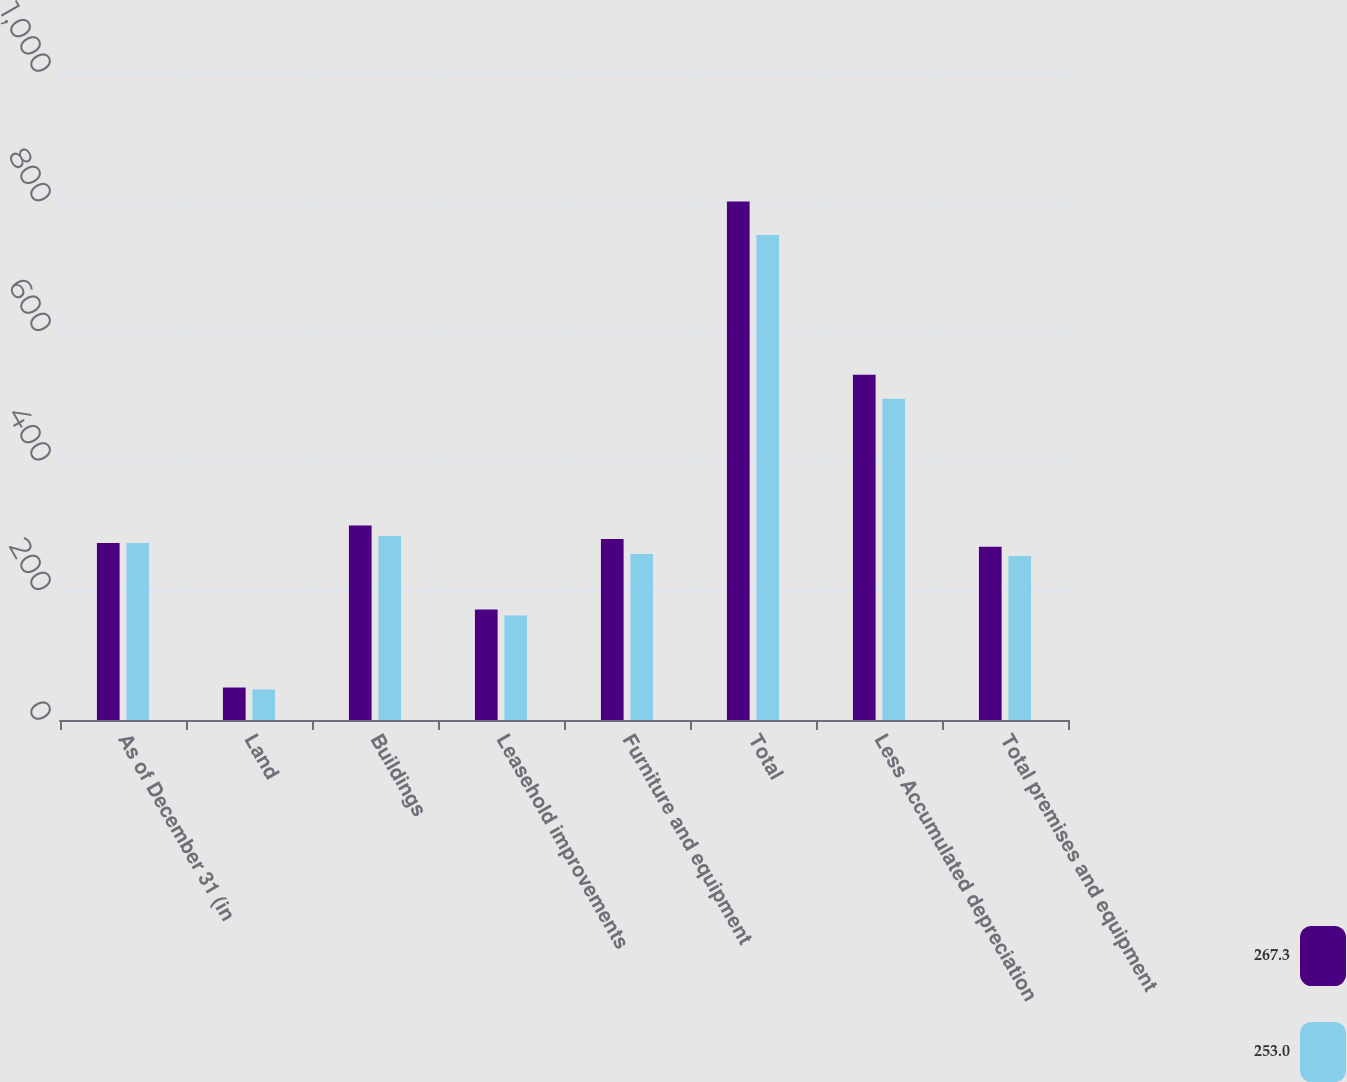Convert chart. <chart><loc_0><loc_0><loc_500><loc_500><stacked_bar_chart><ecel><fcel>As of December 31 (in<fcel>Land<fcel>Buildings<fcel>Leasehold improvements<fcel>Furniture and equipment<fcel>Total<fcel>Less Accumulated depreciation<fcel>Total premises and equipment<nl><fcel>267.3<fcel>273.3<fcel>50.1<fcel>300<fcel>170.7<fcel>279.3<fcel>800.1<fcel>532.8<fcel>267.3<nl><fcel>253<fcel>273.3<fcel>47.2<fcel>283.9<fcel>161.3<fcel>256.2<fcel>748.6<fcel>495.6<fcel>253<nl></chart> 